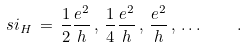Convert formula to latex. <formula><loc_0><loc_0><loc_500><loc_500>\ s i _ { H } \, = \, \frac { 1 } { 2 } \frac { e ^ { 2 } } { h } \, , \, \frac { 1 } { 4 } \frac { e ^ { 2 } } { h } \, , \, \frac { e ^ { 2 } } { h } \, , \, \dots \quad .</formula> 